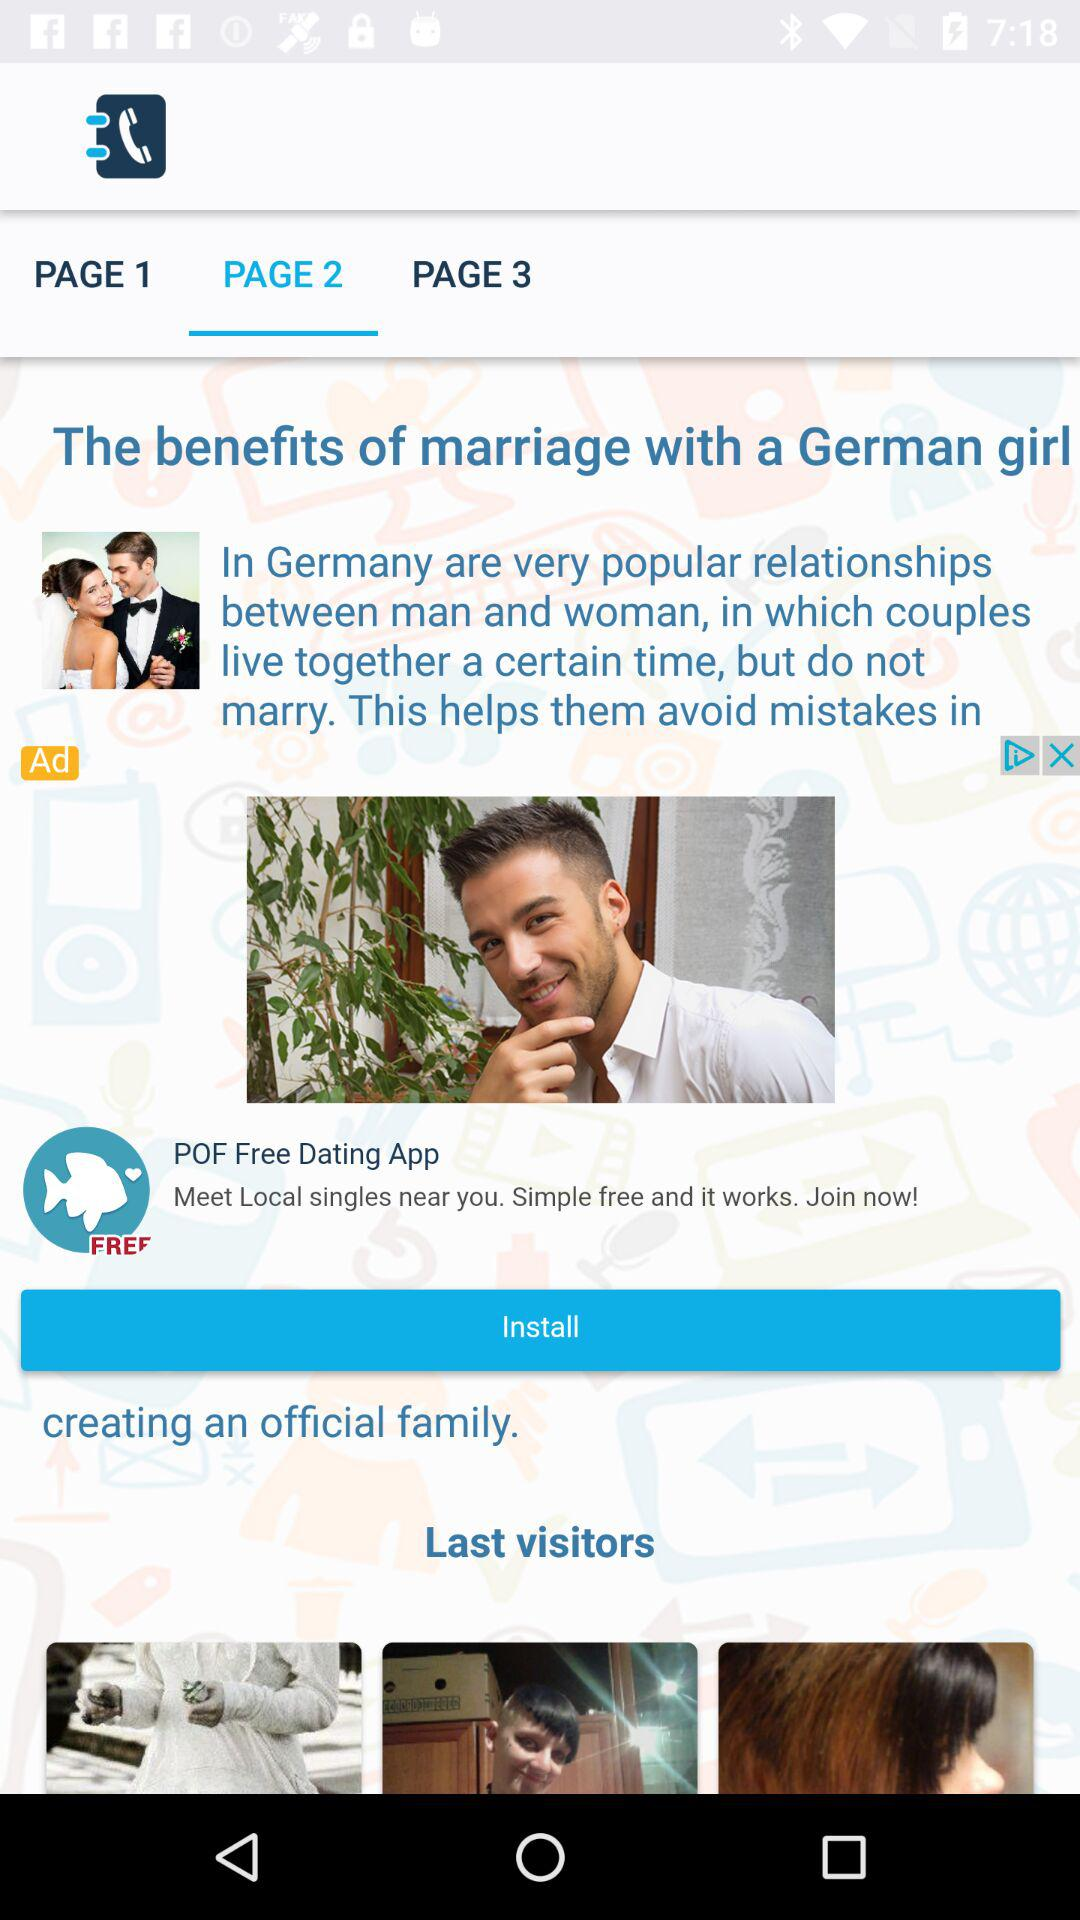Who were the last visitors?
When the provided information is insufficient, respond with <no answer>. <no answer> 